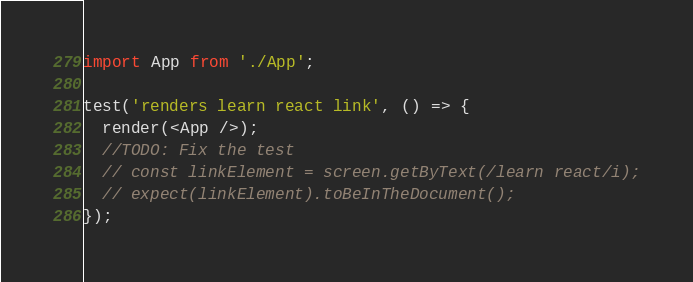<code> <loc_0><loc_0><loc_500><loc_500><_TypeScript_>import App from './App';

test('renders learn react link', () => {
  render(<App />);
  //TODO: Fix the test
  // const linkElement = screen.getByText(/learn react/i);
  // expect(linkElement).toBeInTheDocument();
});
</code> 